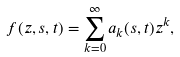<formula> <loc_0><loc_0><loc_500><loc_500>f ( z , s , t ) = \sum _ { k = 0 } ^ { \infty } a _ { k } ( s , t ) z ^ { k } ,</formula> 